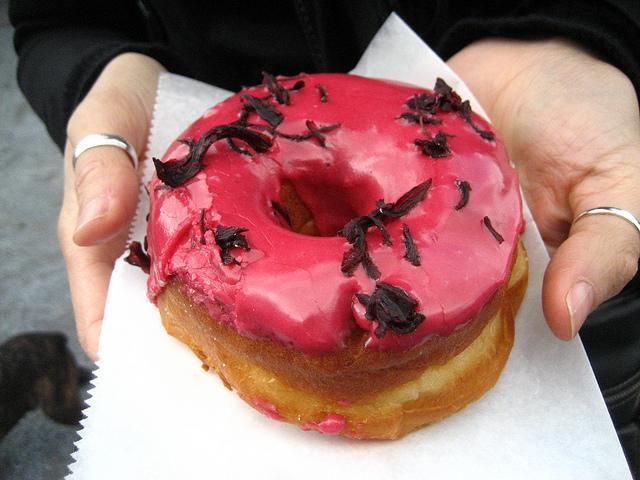Is "The donut is touching the person." an appropriate description for the image?
Answer yes or no. No. 